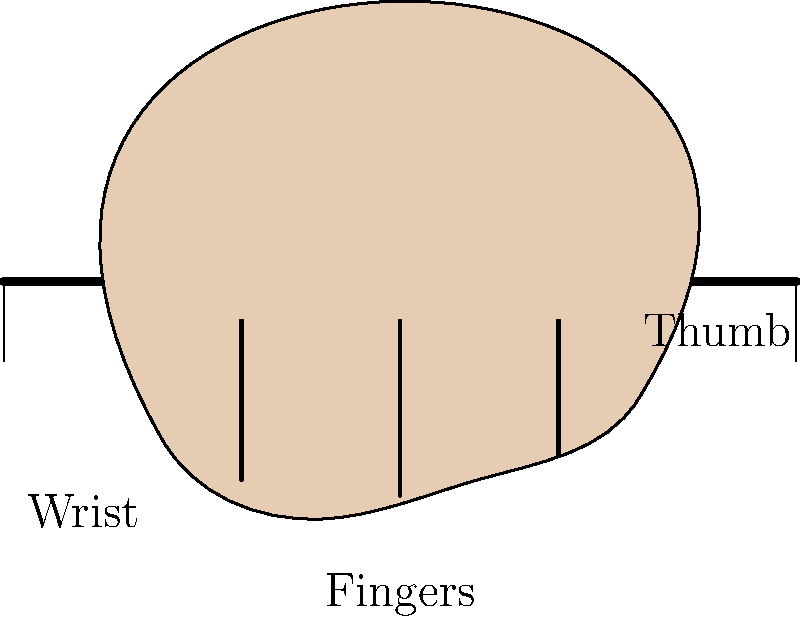In the context of playing a guitar, which biomechanical principle is most important for proper hand positioning on the fretboard, as shown in the diagram? To understand the biomechanical principle for proper hand positioning on a guitar fretboard, let's break it down step-by-step:

1. Wrist alignment: The wrist should be relatively straight, not bent excessively. This reduces strain on the tendons and muscles of the forearm.

2. Finger curvature: The fingers should be curved, forming an arch over the fretboard. This allows for efficient force application and reduces the risk of injury.

3. Thumb position: The thumb should be positioned behind the neck, providing a counterforce to the fingers and stability for the hand.

4. Finger spacing: The fingers should be spread to cover multiple frets, with each fingertip close to perpendicular to the strings.

5. Minimal tension: The hand should maintain a relaxed posture while still providing enough force to press the strings.

The principle that encompasses all these factors is the concept of ergonomics, which aims to optimize human well-being and overall system performance. In this case, proper ergonomics allows for efficient playing while minimizing the risk of repetitive strain injuries.

The biomechanical principle most important here is maintaining a neutral joint position. This principle states that joints should be kept in a middle range of motion, avoiding extreme flexion or extension. For guitar playing, this applies to the wrist, finger joints, and thumb, allowing for optimal force generation and reduced strain on muscles and tendons.
Answer: Neutral joint position 